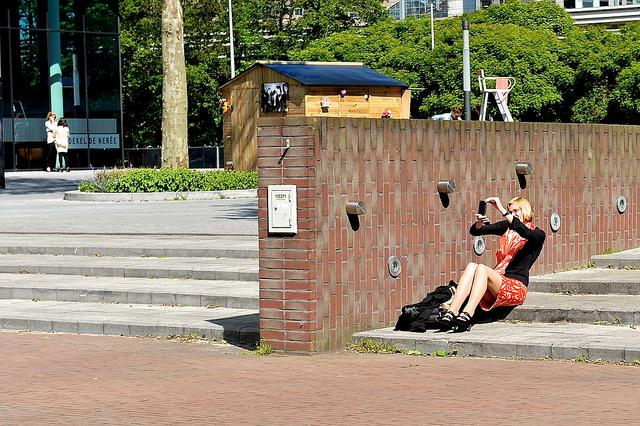Why does the woman have her arms out? taking selfie 